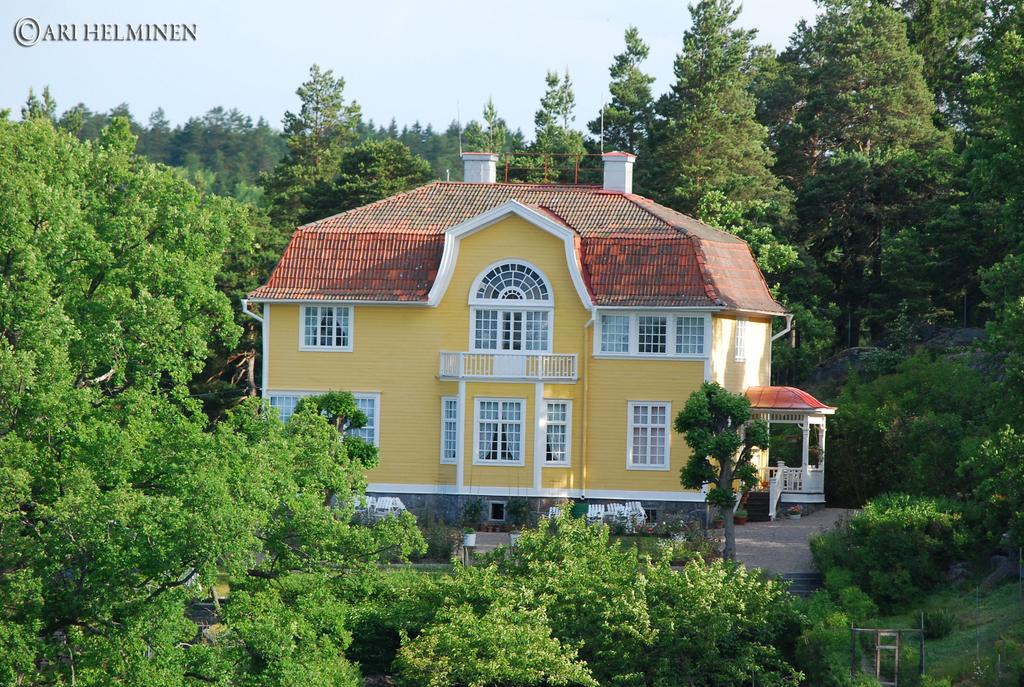What is the main subject of the image? There is a house in the middle of the image. What can be seen in the background of the image? The background of the image includes trees and text. What is visible above the trees and text? The sky is visible in the background of the image. When was the image taken? The image was taken during the day. What type of celery is being used as a writing instrument by the writer in the image? There is no celery or writer present in the image. 